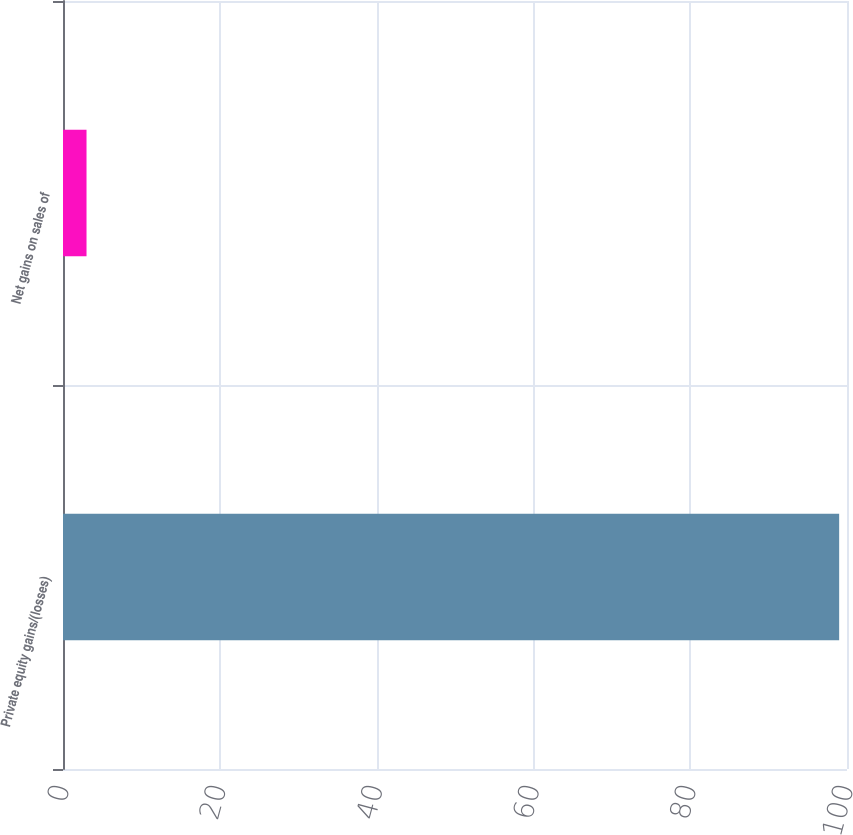Convert chart to OTSL. <chart><loc_0><loc_0><loc_500><loc_500><bar_chart><fcel>Private equity gains/(losses)<fcel>Net gains on sales of<nl><fcel>99<fcel>3<nl></chart> 